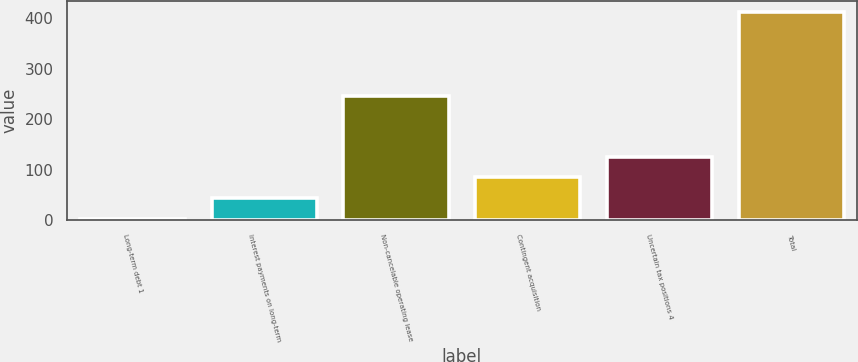<chart> <loc_0><loc_0><loc_500><loc_500><bar_chart><fcel>Long-term debt 1<fcel>Interest payments on long-term<fcel>Non-cancelable operating lease<fcel>Contingent acquisition<fcel>Uncertain tax positions 4<fcel>Total<nl><fcel>2.3<fcel>43.38<fcel>245.3<fcel>84.46<fcel>125.54<fcel>413.1<nl></chart> 